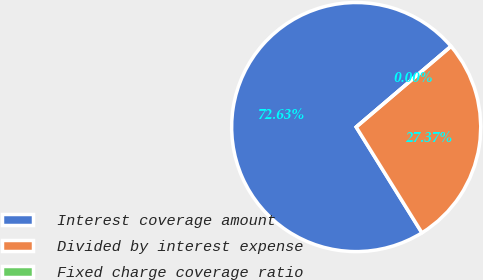<chart> <loc_0><loc_0><loc_500><loc_500><pie_chart><fcel>Interest coverage amount<fcel>Divided by interest expense<fcel>Fixed charge coverage ratio<nl><fcel>72.63%<fcel>27.37%<fcel>0.0%<nl></chart> 